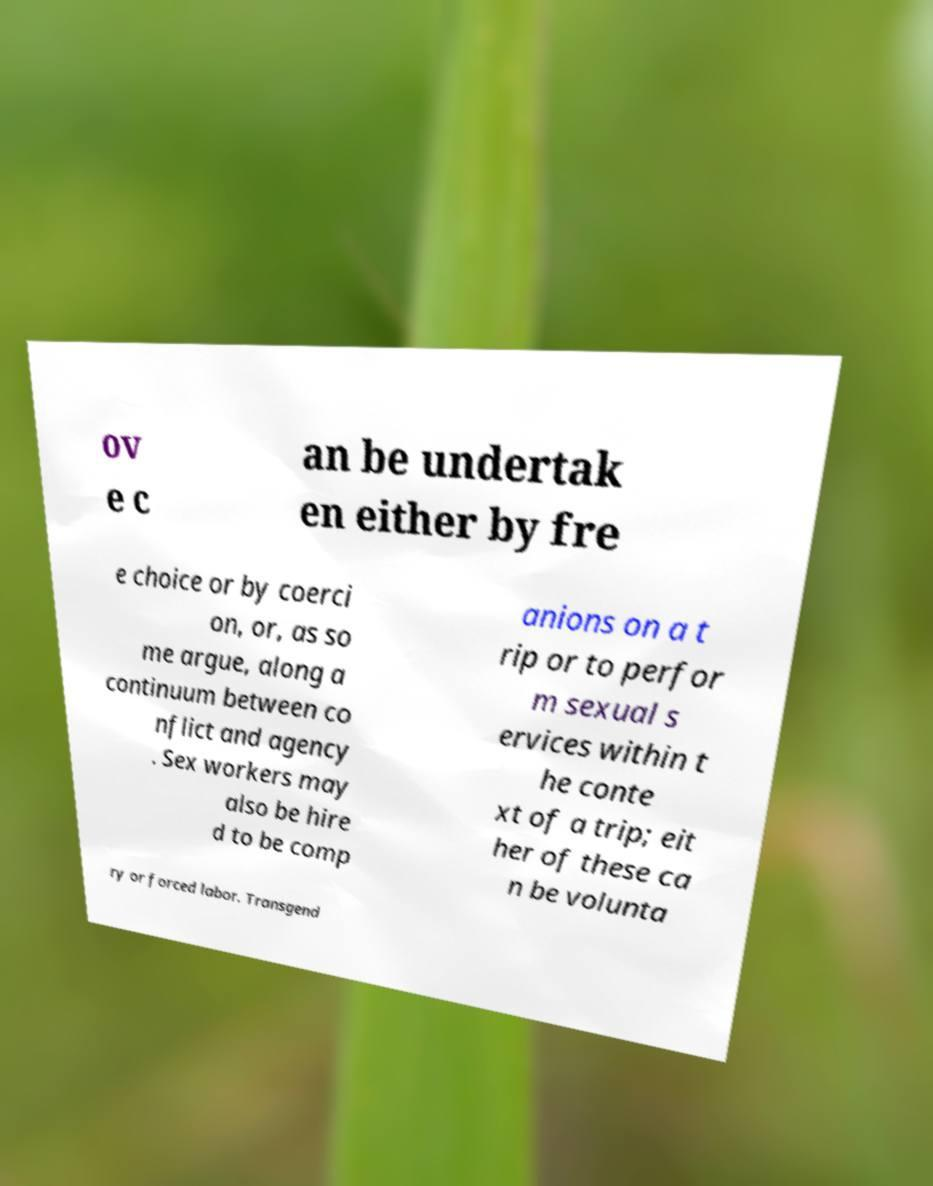I need the written content from this picture converted into text. Can you do that? ov e c an be undertak en either by fre e choice or by coerci on, or, as so me argue, along a continuum between co nflict and agency . Sex workers may also be hire d to be comp anions on a t rip or to perfor m sexual s ervices within t he conte xt of a trip; eit her of these ca n be volunta ry or forced labor. Transgend 